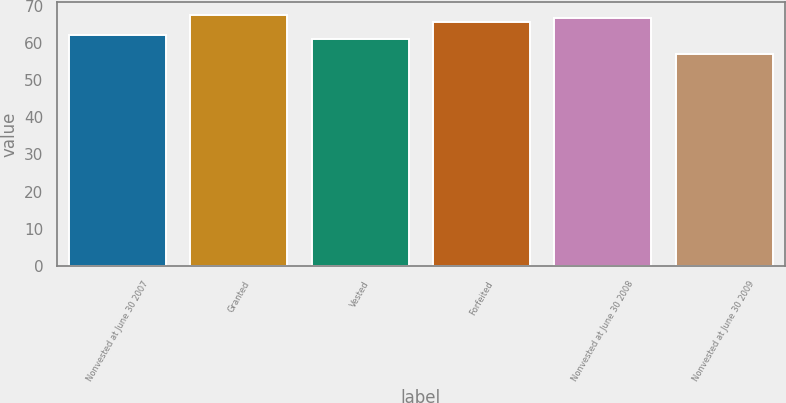Convert chart. <chart><loc_0><loc_0><loc_500><loc_500><bar_chart><fcel>Nonvested at June 30 2007<fcel>Granted<fcel>Vested<fcel>Forfeited<fcel>Nonvested at June 30 2008<fcel>Nonvested at June 30 2009<nl><fcel>62.08<fcel>67.48<fcel>61.13<fcel>65.58<fcel>66.53<fcel>57.1<nl></chart> 